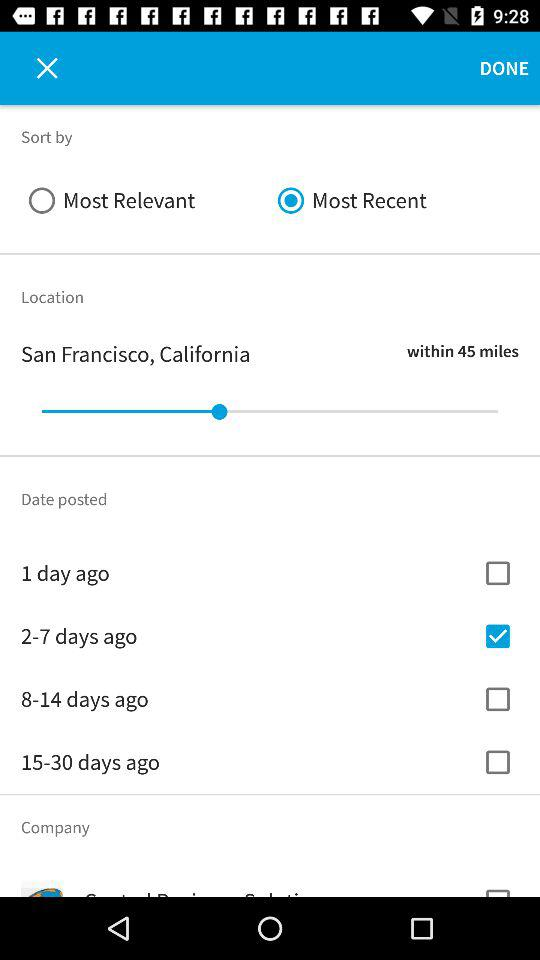Which is the selected option in the sort by? The selected option in the sort by is "Most Recent". 